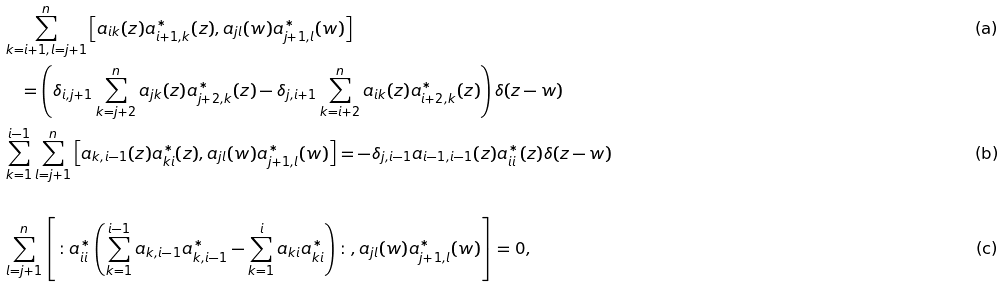<formula> <loc_0><loc_0><loc_500><loc_500>& \sum _ { k = i + 1 , l = j + 1 } ^ { n } \left [ a _ { i k } ( z ) a _ { i + 1 , k } ^ { * } ( z ) , a _ { j l } ( w ) a _ { j + 1 , l } ^ { * } ( w ) \right ] \tag a \\ & \quad = \left ( \delta _ { i , j + 1 } \sum _ { k = j + 2 } ^ { n } a _ { j k } ( z ) a _ { j + 2 , k } ^ { * } ( z ) - \delta _ { j , i + 1 } \sum _ { k = i + 2 } ^ { n } a _ { i k } ( z ) a _ { i + 2 , k } ^ { * } ( z ) \right ) \delta ( z - w ) \\ & \sum _ { k = 1 } ^ { i - 1 } \sum _ { l = j + 1 } ^ { n } \left [ a _ { k , i - 1 } ( z ) a _ { k i } ^ { * } ( z ) , a _ { j l } ( w ) a _ { j + 1 , l } ^ { * } ( w ) \right ] = - \delta _ { j , i - 1 } a _ { i - 1 , i - 1 } ( z ) a ^ { * } _ { i i } ( z ) \delta ( z - w ) \tag b \\ \\ & \sum _ { l = j + 1 } ^ { n } \left [ \colon a _ { i i } ^ { * } \left ( \sum _ { k = 1 } ^ { i - 1 } a _ { k , i - 1 } a _ { k , i - 1 } ^ { * } - \sum _ { k = 1 } ^ { i } a _ { k i } a ^ { * } _ { k i } \right ) \colon , a _ { j l } ( w ) a _ { j + 1 , l } ^ { * } ( w ) \right ] = 0 , \tag c \\ \\</formula> 